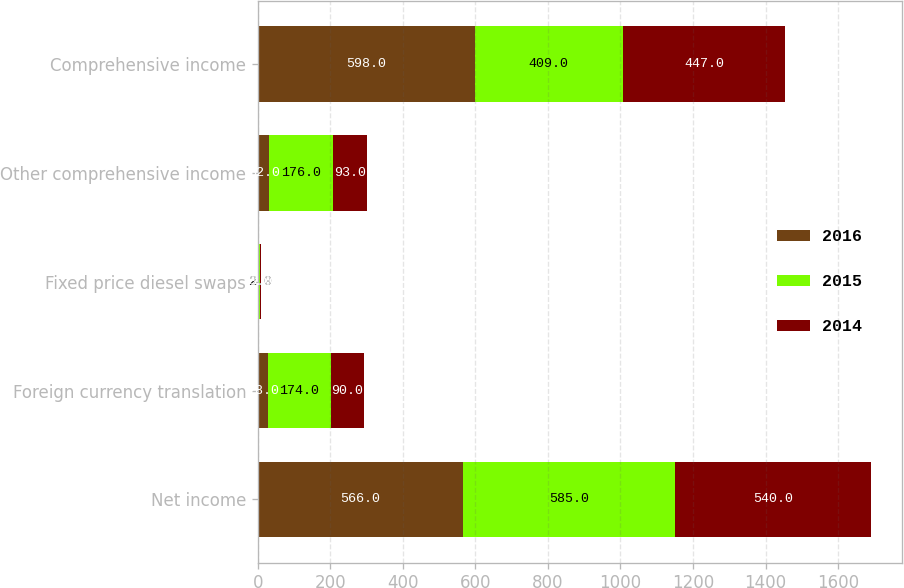<chart> <loc_0><loc_0><loc_500><loc_500><stacked_bar_chart><ecel><fcel>Net income<fcel>Foreign currency translation<fcel>Fixed price diesel swaps<fcel>Other comprehensive income<fcel>Comprehensive income<nl><fcel>2016<fcel>566<fcel>28<fcel>4<fcel>32<fcel>598<nl><fcel>2015<fcel>585<fcel>174<fcel>2<fcel>176<fcel>409<nl><fcel>2014<fcel>540<fcel>90<fcel>3<fcel>93<fcel>447<nl></chart> 